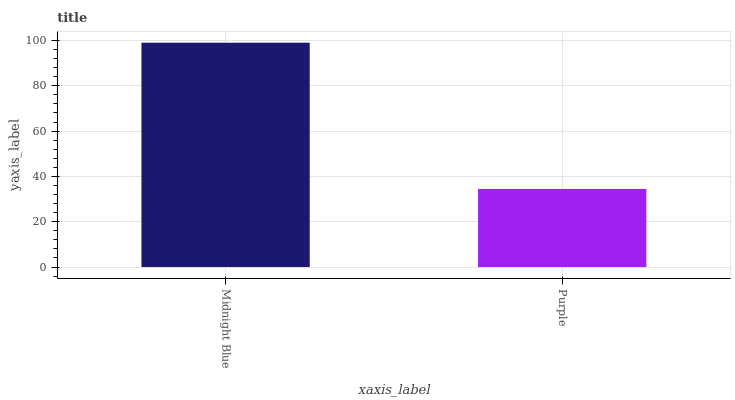Is Purple the minimum?
Answer yes or no. Yes. Is Midnight Blue the maximum?
Answer yes or no. Yes. Is Purple the maximum?
Answer yes or no. No. Is Midnight Blue greater than Purple?
Answer yes or no. Yes. Is Purple less than Midnight Blue?
Answer yes or no. Yes. Is Purple greater than Midnight Blue?
Answer yes or no. No. Is Midnight Blue less than Purple?
Answer yes or no. No. Is Midnight Blue the high median?
Answer yes or no. Yes. Is Purple the low median?
Answer yes or no. Yes. Is Purple the high median?
Answer yes or no. No. Is Midnight Blue the low median?
Answer yes or no. No. 